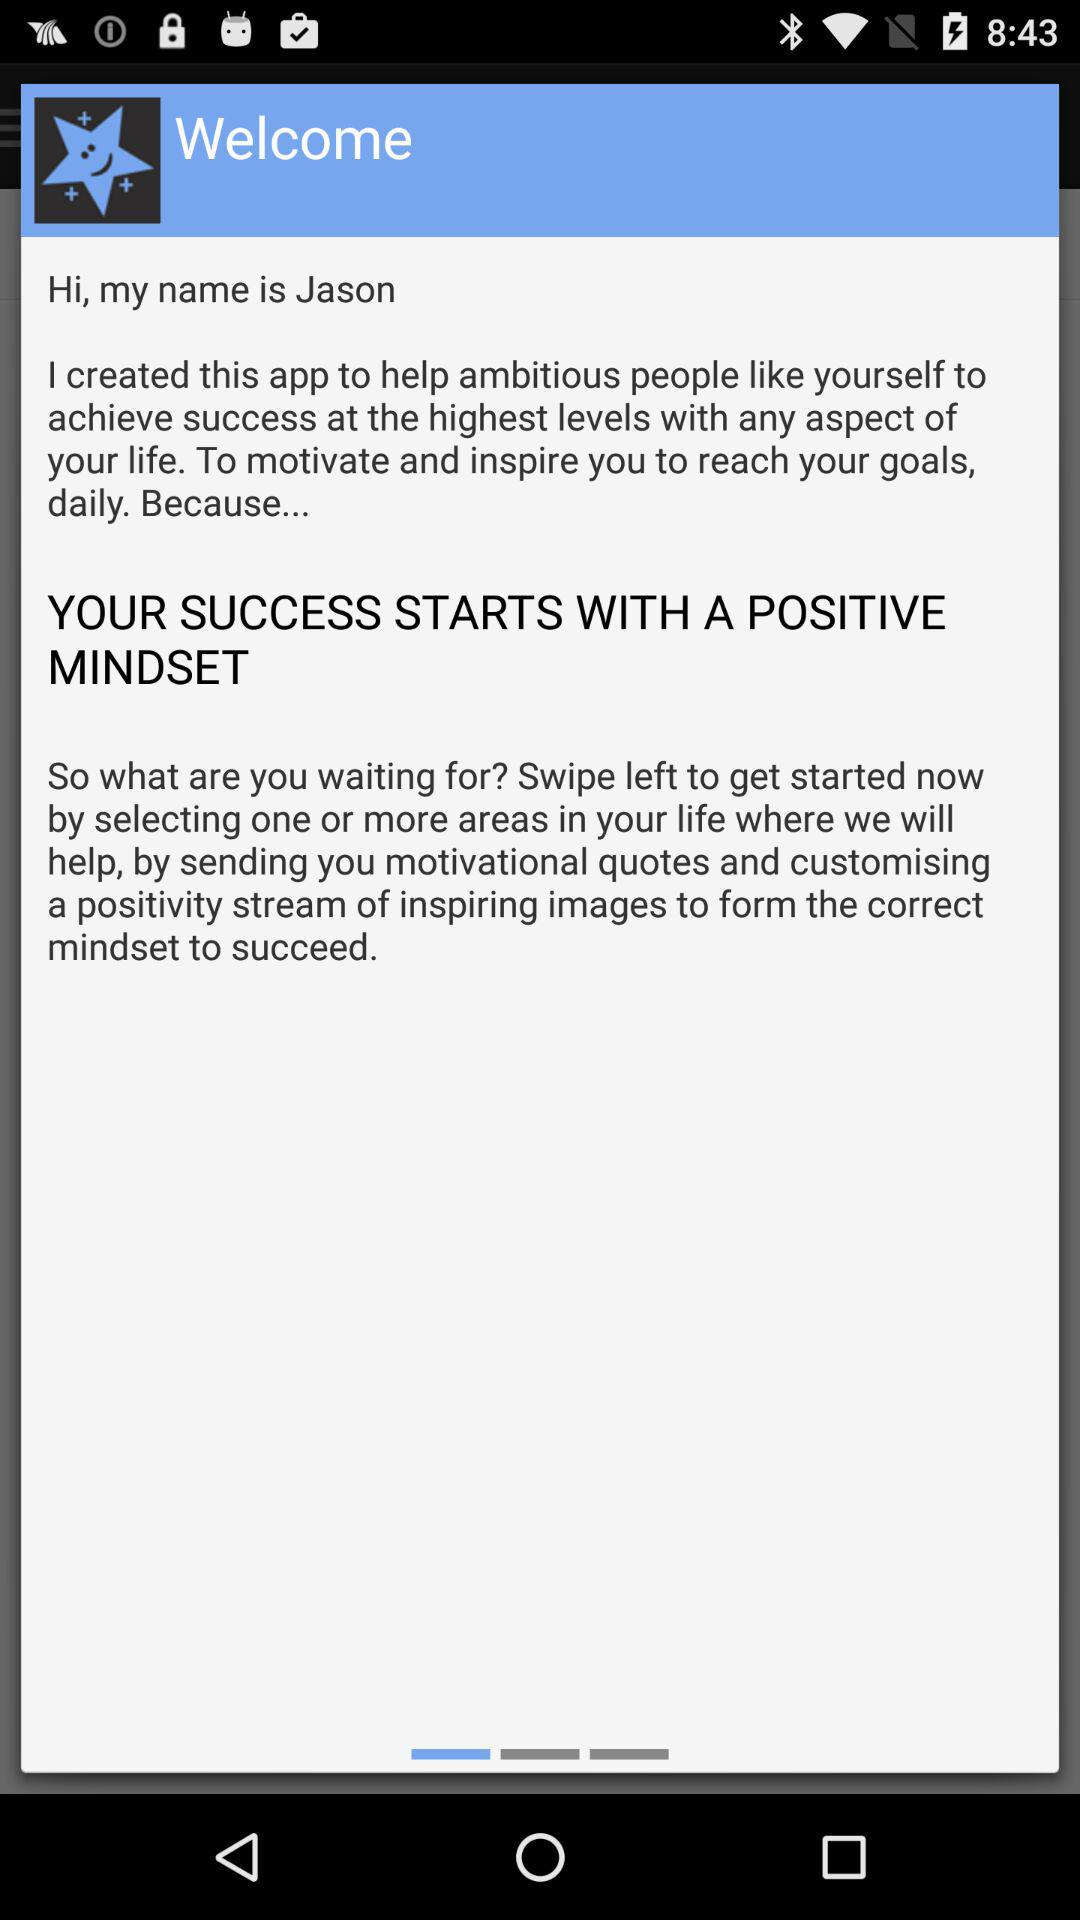What is the name of the person? The name of the person is Jason. 